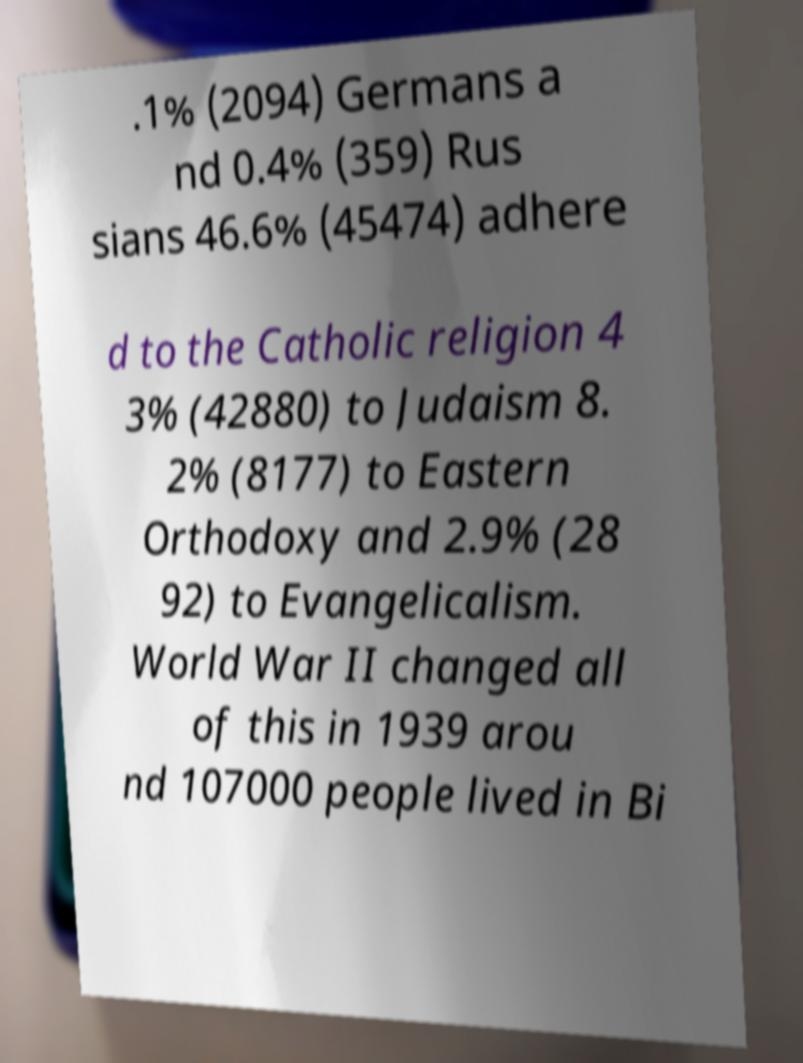Could you assist in decoding the text presented in this image and type it out clearly? .1% (2094) Germans a nd 0.4% (359) Rus sians 46.6% (45474) adhere d to the Catholic religion 4 3% (42880) to Judaism 8. 2% (8177) to Eastern Orthodoxy and 2.9% (28 92) to Evangelicalism. World War II changed all of this in 1939 arou nd 107000 people lived in Bi 